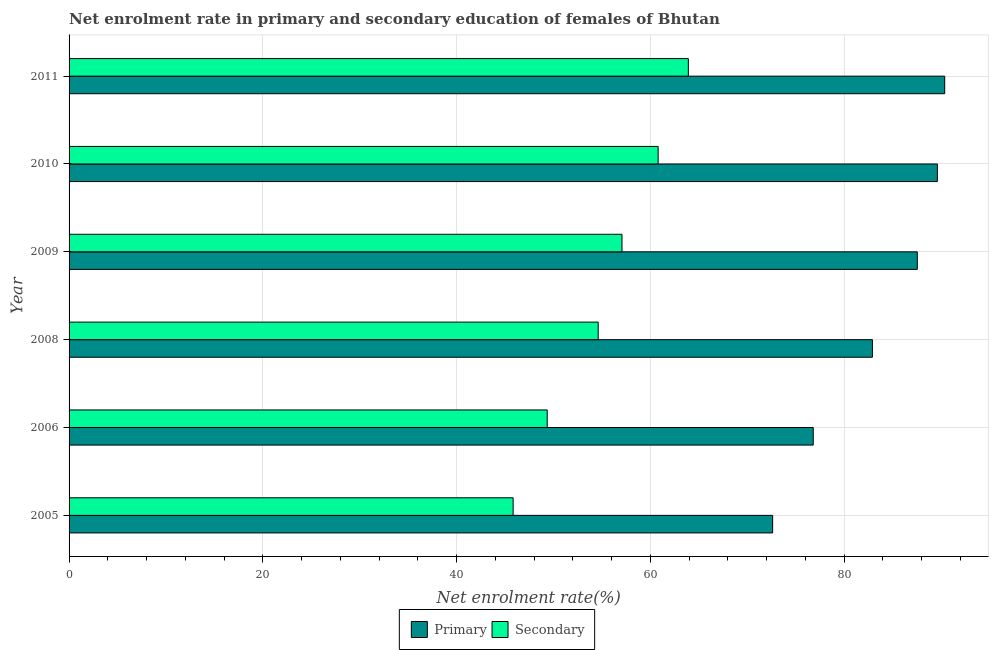How many bars are there on the 2nd tick from the top?
Give a very brief answer. 2. How many bars are there on the 2nd tick from the bottom?
Your answer should be very brief. 2. What is the label of the 2nd group of bars from the top?
Provide a succinct answer. 2010. In how many cases, is the number of bars for a given year not equal to the number of legend labels?
Your answer should be compact. 0. What is the enrollment rate in primary education in 2008?
Provide a short and direct response. 82.93. Across all years, what is the maximum enrollment rate in primary education?
Your answer should be very brief. 90.39. Across all years, what is the minimum enrollment rate in secondary education?
Give a very brief answer. 45.84. In which year was the enrollment rate in primary education maximum?
Provide a succinct answer. 2011. In which year was the enrollment rate in secondary education minimum?
Your answer should be compact. 2005. What is the total enrollment rate in secondary education in the graph?
Offer a very short reply. 331.63. What is the difference between the enrollment rate in secondary education in 2005 and that in 2011?
Ensure brevity in your answer.  -18.09. What is the difference between the enrollment rate in secondary education in 2005 and the enrollment rate in primary education in 2010?
Ensure brevity in your answer.  -43.79. What is the average enrollment rate in primary education per year?
Your answer should be compact. 83.33. In the year 2005, what is the difference between the enrollment rate in primary education and enrollment rate in secondary education?
Make the answer very short. 26.79. In how many years, is the enrollment rate in primary education greater than 8 %?
Provide a succinct answer. 6. What is the ratio of the enrollment rate in secondary education in 2006 to that in 2010?
Ensure brevity in your answer.  0.81. What is the difference between the highest and the second highest enrollment rate in primary education?
Your response must be concise. 0.76. What is the difference between the highest and the lowest enrollment rate in primary education?
Offer a very short reply. 17.76. What does the 1st bar from the top in 2011 represents?
Make the answer very short. Secondary. What does the 2nd bar from the bottom in 2010 represents?
Give a very brief answer. Secondary. How many bars are there?
Make the answer very short. 12. Are the values on the major ticks of X-axis written in scientific E-notation?
Keep it short and to the point. No. Does the graph contain any zero values?
Ensure brevity in your answer.  No. Does the graph contain grids?
Your response must be concise. Yes. Where does the legend appear in the graph?
Provide a succinct answer. Bottom center. How many legend labels are there?
Your response must be concise. 2. How are the legend labels stacked?
Offer a terse response. Horizontal. What is the title of the graph?
Your answer should be compact. Net enrolment rate in primary and secondary education of females of Bhutan. Does "Sanitation services" appear as one of the legend labels in the graph?
Provide a short and direct response. No. What is the label or title of the X-axis?
Provide a short and direct response. Net enrolment rate(%). What is the label or title of the Y-axis?
Your response must be concise. Year. What is the Net enrolment rate(%) of Primary in 2005?
Offer a terse response. 72.63. What is the Net enrolment rate(%) of Secondary in 2005?
Offer a very short reply. 45.84. What is the Net enrolment rate(%) of Primary in 2006?
Provide a succinct answer. 76.82. What is the Net enrolment rate(%) in Secondary in 2006?
Your response must be concise. 49.36. What is the Net enrolment rate(%) in Primary in 2008?
Keep it short and to the point. 82.93. What is the Net enrolment rate(%) in Secondary in 2008?
Give a very brief answer. 54.62. What is the Net enrolment rate(%) in Primary in 2009?
Your answer should be compact. 87.56. What is the Net enrolment rate(%) of Secondary in 2009?
Provide a short and direct response. 57.08. What is the Net enrolment rate(%) of Primary in 2010?
Make the answer very short. 89.63. What is the Net enrolment rate(%) in Secondary in 2010?
Offer a very short reply. 60.81. What is the Net enrolment rate(%) in Primary in 2011?
Your answer should be very brief. 90.39. What is the Net enrolment rate(%) in Secondary in 2011?
Your response must be concise. 63.93. Across all years, what is the maximum Net enrolment rate(%) of Primary?
Your answer should be compact. 90.39. Across all years, what is the maximum Net enrolment rate(%) in Secondary?
Offer a very short reply. 63.93. Across all years, what is the minimum Net enrolment rate(%) of Primary?
Offer a very short reply. 72.63. Across all years, what is the minimum Net enrolment rate(%) of Secondary?
Make the answer very short. 45.84. What is the total Net enrolment rate(%) of Primary in the graph?
Your answer should be very brief. 499.96. What is the total Net enrolment rate(%) in Secondary in the graph?
Offer a very short reply. 331.63. What is the difference between the Net enrolment rate(%) of Primary in 2005 and that in 2006?
Offer a very short reply. -4.19. What is the difference between the Net enrolment rate(%) of Secondary in 2005 and that in 2006?
Provide a succinct answer. -3.52. What is the difference between the Net enrolment rate(%) of Primary in 2005 and that in 2008?
Give a very brief answer. -10.3. What is the difference between the Net enrolment rate(%) in Secondary in 2005 and that in 2008?
Provide a succinct answer. -8.78. What is the difference between the Net enrolment rate(%) of Primary in 2005 and that in 2009?
Offer a terse response. -14.93. What is the difference between the Net enrolment rate(%) in Secondary in 2005 and that in 2009?
Your answer should be compact. -11.24. What is the difference between the Net enrolment rate(%) in Primary in 2005 and that in 2010?
Offer a terse response. -17. What is the difference between the Net enrolment rate(%) of Secondary in 2005 and that in 2010?
Offer a terse response. -14.97. What is the difference between the Net enrolment rate(%) in Primary in 2005 and that in 2011?
Ensure brevity in your answer.  -17.76. What is the difference between the Net enrolment rate(%) in Secondary in 2005 and that in 2011?
Your answer should be very brief. -18.09. What is the difference between the Net enrolment rate(%) of Primary in 2006 and that in 2008?
Offer a very short reply. -6.11. What is the difference between the Net enrolment rate(%) in Secondary in 2006 and that in 2008?
Offer a very short reply. -5.27. What is the difference between the Net enrolment rate(%) of Primary in 2006 and that in 2009?
Make the answer very short. -10.74. What is the difference between the Net enrolment rate(%) of Secondary in 2006 and that in 2009?
Offer a terse response. -7.72. What is the difference between the Net enrolment rate(%) in Primary in 2006 and that in 2010?
Your answer should be very brief. -12.81. What is the difference between the Net enrolment rate(%) in Secondary in 2006 and that in 2010?
Your answer should be very brief. -11.45. What is the difference between the Net enrolment rate(%) in Primary in 2006 and that in 2011?
Give a very brief answer. -13.57. What is the difference between the Net enrolment rate(%) of Secondary in 2006 and that in 2011?
Make the answer very short. -14.57. What is the difference between the Net enrolment rate(%) in Primary in 2008 and that in 2009?
Your answer should be very brief. -4.63. What is the difference between the Net enrolment rate(%) of Secondary in 2008 and that in 2009?
Give a very brief answer. -2.45. What is the difference between the Net enrolment rate(%) of Primary in 2008 and that in 2010?
Your answer should be compact. -6.71. What is the difference between the Net enrolment rate(%) of Secondary in 2008 and that in 2010?
Make the answer very short. -6.19. What is the difference between the Net enrolment rate(%) in Primary in 2008 and that in 2011?
Provide a short and direct response. -7.46. What is the difference between the Net enrolment rate(%) in Secondary in 2008 and that in 2011?
Ensure brevity in your answer.  -9.3. What is the difference between the Net enrolment rate(%) of Primary in 2009 and that in 2010?
Give a very brief answer. -2.07. What is the difference between the Net enrolment rate(%) in Secondary in 2009 and that in 2010?
Provide a short and direct response. -3.73. What is the difference between the Net enrolment rate(%) in Primary in 2009 and that in 2011?
Give a very brief answer. -2.83. What is the difference between the Net enrolment rate(%) in Secondary in 2009 and that in 2011?
Your answer should be compact. -6.85. What is the difference between the Net enrolment rate(%) in Primary in 2010 and that in 2011?
Make the answer very short. -0.76. What is the difference between the Net enrolment rate(%) in Secondary in 2010 and that in 2011?
Your response must be concise. -3.12. What is the difference between the Net enrolment rate(%) of Primary in 2005 and the Net enrolment rate(%) of Secondary in 2006?
Provide a succinct answer. 23.27. What is the difference between the Net enrolment rate(%) of Primary in 2005 and the Net enrolment rate(%) of Secondary in 2008?
Provide a succinct answer. 18.01. What is the difference between the Net enrolment rate(%) in Primary in 2005 and the Net enrolment rate(%) in Secondary in 2009?
Offer a very short reply. 15.55. What is the difference between the Net enrolment rate(%) of Primary in 2005 and the Net enrolment rate(%) of Secondary in 2010?
Provide a short and direct response. 11.82. What is the difference between the Net enrolment rate(%) of Primary in 2005 and the Net enrolment rate(%) of Secondary in 2011?
Provide a succinct answer. 8.7. What is the difference between the Net enrolment rate(%) of Primary in 2006 and the Net enrolment rate(%) of Secondary in 2008?
Offer a very short reply. 22.2. What is the difference between the Net enrolment rate(%) of Primary in 2006 and the Net enrolment rate(%) of Secondary in 2009?
Make the answer very short. 19.74. What is the difference between the Net enrolment rate(%) of Primary in 2006 and the Net enrolment rate(%) of Secondary in 2010?
Keep it short and to the point. 16.01. What is the difference between the Net enrolment rate(%) in Primary in 2006 and the Net enrolment rate(%) in Secondary in 2011?
Provide a short and direct response. 12.89. What is the difference between the Net enrolment rate(%) in Primary in 2008 and the Net enrolment rate(%) in Secondary in 2009?
Provide a short and direct response. 25.85. What is the difference between the Net enrolment rate(%) in Primary in 2008 and the Net enrolment rate(%) in Secondary in 2010?
Your response must be concise. 22.12. What is the difference between the Net enrolment rate(%) of Primary in 2008 and the Net enrolment rate(%) of Secondary in 2011?
Offer a very short reply. 19. What is the difference between the Net enrolment rate(%) of Primary in 2009 and the Net enrolment rate(%) of Secondary in 2010?
Provide a succinct answer. 26.75. What is the difference between the Net enrolment rate(%) of Primary in 2009 and the Net enrolment rate(%) of Secondary in 2011?
Offer a very short reply. 23.63. What is the difference between the Net enrolment rate(%) in Primary in 2010 and the Net enrolment rate(%) in Secondary in 2011?
Keep it short and to the point. 25.71. What is the average Net enrolment rate(%) in Primary per year?
Provide a succinct answer. 83.33. What is the average Net enrolment rate(%) in Secondary per year?
Offer a very short reply. 55.27. In the year 2005, what is the difference between the Net enrolment rate(%) in Primary and Net enrolment rate(%) in Secondary?
Keep it short and to the point. 26.79. In the year 2006, what is the difference between the Net enrolment rate(%) in Primary and Net enrolment rate(%) in Secondary?
Your answer should be compact. 27.46. In the year 2008, what is the difference between the Net enrolment rate(%) in Primary and Net enrolment rate(%) in Secondary?
Offer a very short reply. 28.31. In the year 2009, what is the difference between the Net enrolment rate(%) in Primary and Net enrolment rate(%) in Secondary?
Offer a very short reply. 30.48. In the year 2010, what is the difference between the Net enrolment rate(%) in Primary and Net enrolment rate(%) in Secondary?
Keep it short and to the point. 28.82. In the year 2011, what is the difference between the Net enrolment rate(%) in Primary and Net enrolment rate(%) in Secondary?
Your answer should be very brief. 26.46. What is the ratio of the Net enrolment rate(%) of Primary in 2005 to that in 2006?
Ensure brevity in your answer.  0.95. What is the ratio of the Net enrolment rate(%) of Secondary in 2005 to that in 2006?
Make the answer very short. 0.93. What is the ratio of the Net enrolment rate(%) of Primary in 2005 to that in 2008?
Your answer should be compact. 0.88. What is the ratio of the Net enrolment rate(%) in Secondary in 2005 to that in 2008?
Make the answer very short. 0.84. What is the ratio of the Net enrolment rate(%) of Primary in 2005 to that in 2009?
Your response must be concise. 0.83. What is the ratio of the Net enrolment rate(%) in Secondary in 2005 to that in 2009?
Keep it short and to the point. 0.8. What is the ratio of the Net enrolment rate(%) of Primary in 2005 to that in 2010?
Provide a short and direct response. 0.81. What is the ratio of the Net enrolment rate(%) of Secondary in 2005 to that in 2010?
Provide a short and direct response. 0.75. What is the ratio of the Net enrolment rate(%) of Primary in 2005 to that in 2011?
Make the answer very short. 0.8. What is the ratio of the Net enrolment rate(%) of Secondary in 2005 to that in 2011?
Your answer should be very brief. 0.72. What is the ratio of the Net enrolment rate(%) of Primary in 2006 to that in 2008?
Ensure brevity in your answer.  0.93. What is the ratio of the Net enrolment rate(%) of Secondary in 2006 to that in 2008?
Provide a succinct answer. 0.9. What is the ratio of the Net enrolment rate(%) of Primary in 2006 to that in 2009?
Offer a terse response. 0.88. What is the ratio of the Net enrolment rate(%) of Secondary in 2006 to that in 2009?
Your answer should be compact. 0.86. What is the ratio of the Net enrolment rate(%) in Primary in 2006 to that in 2010?
Provide a short and direct response. 0.86. What is the ratio of the Net enrolment rate(%) of Secondary in 2006 to that in 2010?
Provide a succinct answer. 0.81. What is the ratio of the Net enrolment rate(%) in Primary in 2006 to that in 2011?
Provide a short and direct response. 0.85. What is the ratio of the Net enrolment rate(%) of Secondary in 2006 to that in 2011?
Offer a very short reply. 0.77. What is the ratio of the Net enrolment rate(%) in Primary in 2008 to that in 2009?
Make the answer very short. 0.95. What is the ratio of the Net enrolment rate(%) in Secondary in 2008 to that in 2009?
Ensure brevity in your answer.  0.96. What is the ratio of the Net enrolment rate(%) in Primary in 2008 to that in 2010?
Offer a terse response. 0.93. What is the ratio of the Net enrolment rate(%) in Secondary in 2008 to that in 2010?
Your response must be concise. 0.9. What is the ratio of the Net enrolment rate(%) of Primary in 2008 to that in 2011?
Your response must be concise. 0.92. What is the ratio of the Net enrolment rate(%) in Secondary in 2008 to that in 2011?
Offer a very short reply. 0.85. What is the ratio of the Net enrolment rate(%) in Primary in 2009 to that in 2010?
Your answer should be very brief. 0.98. What is the ratio of the Net enrolment rate(%) of Secondary in 2009 to that in 2010?
Your answer should be very brief. 0.94. What is the ratio of the Net enrolment rate(%) in Primary in 2009 to that in 2011?
Offer a very short reply. 0.97. What is the ratio of the Net enrolment rate(%) of Secondary in 2009 to that in 2011?
Provide a succinct answer. 0.89. What is the ratio of the Net enrolment rate(%) in Primary in 2010 to that in 2011?
Keep it short and to the point. 0.99. What is the ratio of the Net enrolment rate(%) in Secondary in 2010 to that in 2011?
Your answer should be compact. 0.95. What is the difference between the highest and the second highest Net enrolment rate(%) of Primary?
Provide a short and direct response. 0.76. What is the difference between the highest and the second highest Net enrolment rate(%) in Secondary?
Your answer should be compact. 3.12. What is the difference between the highest and the lowest Net enrolment rate(%) in Primary?
Offer a very short reply. 17.76. What is the difference between the highest and the lowest Net enrolment rate(%) in Secondary?
Your answer should be compact. 18.09. 